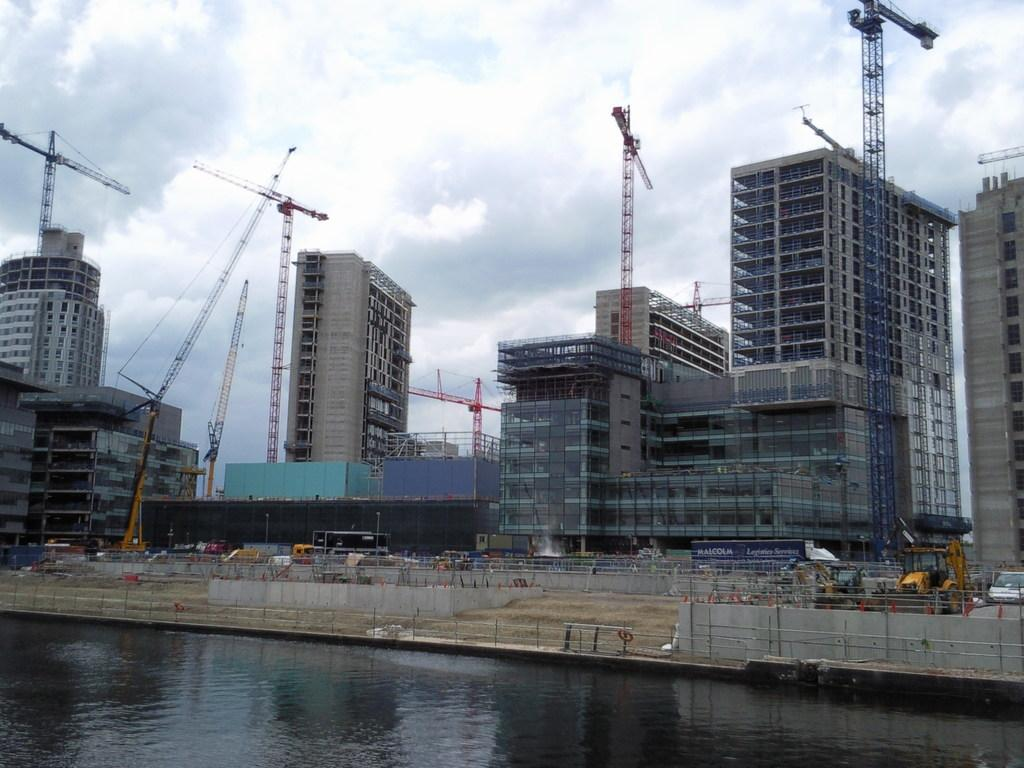What is present in the image that is not solid? There is water visible in the image. What type of transportation can be seen in the image? There are vehicles on the road in the image. What can be seen in the distance in the image? There are buildings in the background of the image. What is visible in the sky in the background of the image? Clouds are visible in the sky in the background of the image. How many clocks are hanging on the buildings in the image? There is no mention of clocks in the image, so it is impossible to determine their presence or quantity. 